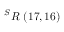Convert formula to latex. <formula><loc_0><loc_0><loc_500><loc_500>^ { S } R \ ( 1 7 , 1 6 )</formula> 